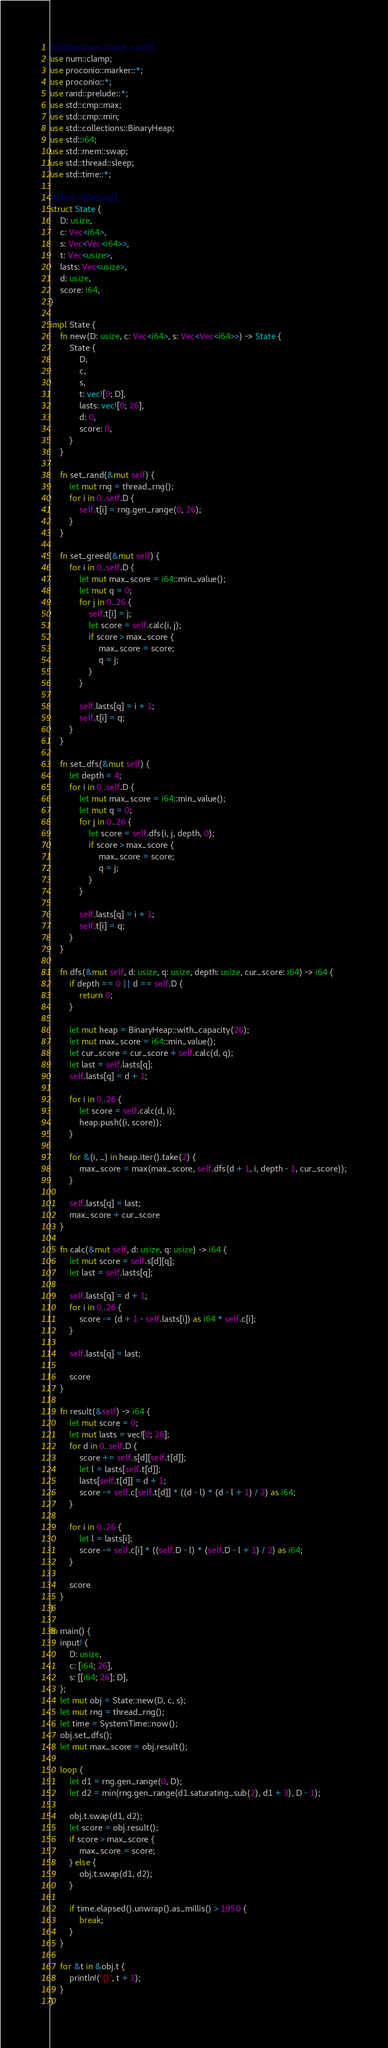<code> <loc_0><loc_0><loc_500><loc_500><_Rust_>#![allow(non_snake_case)]
use num::clamp;
use proconio::marker::*;
use proconio::*;
use rand::prelude::*;
use std::cmp::max;
use std::cmp::min;
use std::collections::BinaryHeap;
use std::i64;
use std::mem::swap;
use std::thread::sleep;
use std::time::*;

#[derive(Debug)]
struct State {
    D: usize,
    c: Vec<i64>,
    s: Vec<Vec<i64>>,
    t: Vec<usize>,
    lasts: Vec<usize>,
    d: usize,
    score: i64,
}

impl State {
    fn new(D: usize, c: Vec<i64>, s: Vec<Vec<i64>>) -> State {
        State {
            D,
            c,
            s,
            t: vec![0; D],
            lasts: vec![0; 26],
            d: 0,
            score: 0,
        }
    }

    fn set_rand(&mut self) {
        let mut rng = thread_rng();
        for i in 0..self.D {
            self.t[i] = rng.gen_range(0, 26);
        }
    }

    fn set_greed(&mut self) {
        for i in 0..self.D {
            let mut max_score = i64::min_value();
            let mut q = 0;
            for j in 0..26 {
                self.t[i] = j;
                let score = self.calc(i, j);
                if score > max_score {
                    max_score = score;
                    q = j;
                }
            }

            self.lasts[q] = i + 1;
            self.t[i] = q;
        }
    }

    fn set_dfs(&mut self) {
        let depth = 4;
        for i in 0..self.D {
            let mut max_score = i64::min_value();
            let mut q = 0;
            for j in 0..26 {
                let score = self.dfs(i, j, depth, 0);
                if score > max_score {
                    max_score = score;
                    q = j;
                }
            }

            self.lasts[q] = i + 1;
            self.t[i] = q;
        }
    }

    fn dfs(&mut self, d: usize, q: usize, depth: usize, cur_score: i64) -> i64 {
        if depth == 0 || d == self.D {
            return 0;
        }

        let mut heap = BinaryHeap::with_capacity(26);
        let mut max_score = i64::min_value();
        let cur_score = cur_score + self.calc(d, q);
        let last = self.lasts[q];
        self.lasts[q] = d + 1;

        for i in 0..26 {
            let score = self.calc(d, i);
            heap.push((i, score));
        }

        for &(i, _) in heap.iter().take(2) {
            max_score = max(max_score, self.dfs(d + 1, i, depth - 1, cur_score));
        }

        self.lasts[q] = last;
        max_score + cur_score
    }

    fn calc(&mut self, d: usize, q: usize) -> i64 {
        let mut score = self.s[d][q];
        let last = self.lasts[q];

        self.lasts[q] = d + 1;
        for i in 0..26 {
            score -= (d + 1 - self.lasts[i]) as i64 * self.c[i];
        }

        self.lasts[q] = last;

        score
    }

    fn result(&self) -> i64 {
        let mut score = 0;
        let mut lasts = vec![0; 26];
        for d in 0..self.D {
            score += self.s[d][self.t[d]];
            let l = lasts[self.t[d]];
            lasts[self.t[d]] = d + 1;
            score -= self.c[self.t[d]] * ((d - l) * (d - l + 1) / 2) as i64;
        }

        for i in 0..26 {
            let l = lasts[i];
            score -= self.c[i] * ((self.D - l) * (self.D - l + 1) / 2) as i64;
        }

        score
    }
}

fn main() {
    input! {
        D: usize,
        c: [i64; 26],
        s: [[i64; 26]; D],
    };
    let mut obj = State::new(D, c, s);
    let mut rng = thread_rng();
    let time = SystemTime::now();
    obj.set_dfs();
    let mut max_score = obj.result();

    loop {
        let d1 = rng.gen_range(0, D);
        let d2 = min(rng.gen_range(d1.saturating_sub(2), d1 + 3), D - 1);

        obj.t.swap(d1, d2);
        let score = obj.result();
        if score > max_score {
            max_score = score;
        } else {
            obj.t.swap(d1, d2);
        }

        if time.elapsed().unwrap().as_millis() > 1950 {
            break;
        }
    }

    for &t in &obj.t {
        println!("{}", t + 1);
    }
}
</code> 